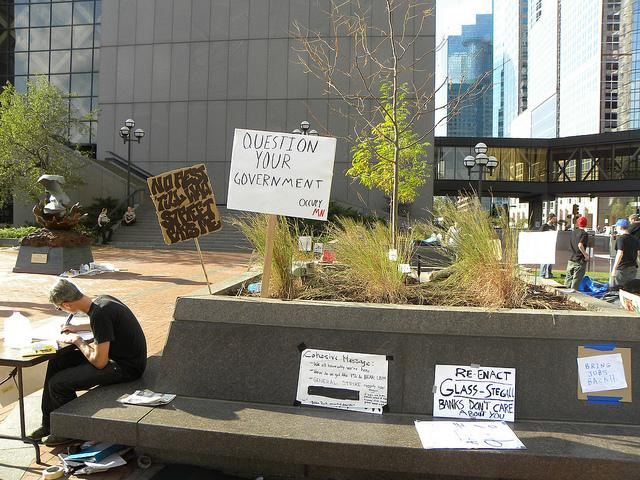What is the man participating in? Please explain your reasoning. protest. The man is making signs for people to hold up in a protest he is participating in. 